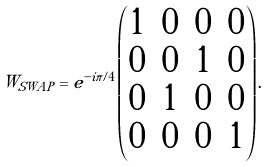Convert formula to latex. <formula><loc_0><loc_0><loc_500><loc_500>W _ { S W A P } = e ^ { - i \pi / 4 } \begin{pmatrix} 1 & 0 & 0 & 0 \\ 0 & 0 & 1 & 0 \\ 0 & 1 & 0 & 0 \\ 0 & 0 & 0 & 1 \\ \end{pmatrix} .</formula> 